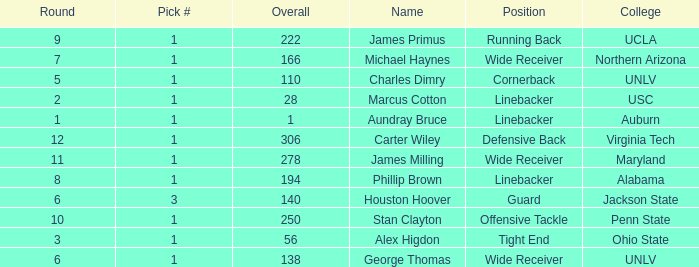What was the first Round with a Pick # greater than 1 and 140 Overall? None. 